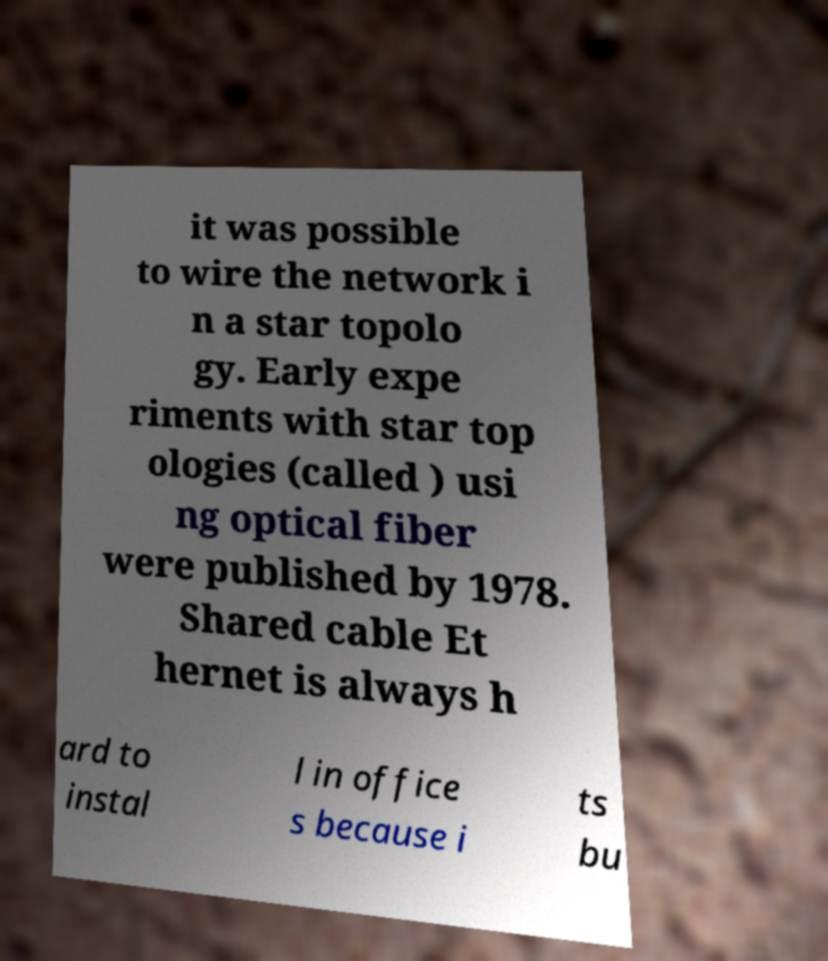Please identify and transcribe the text found in this image. it was possible to wire the network i n a star topolo gy. Early expe riments with star top ologies (called ) usi ng optical fiber were published by 1978. Shared cable Et hernet is always h ard to instal l in office s because i ts bu 